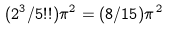Convert formula to latex. <formula><loc_0><loc_0><loc_500><loc_500>( 2 ^ { 3 } / 5 ! ! ) \pi ^ { 2 } = ( 8 / 1 5 ) \pi ^ { 2 }</formula> 